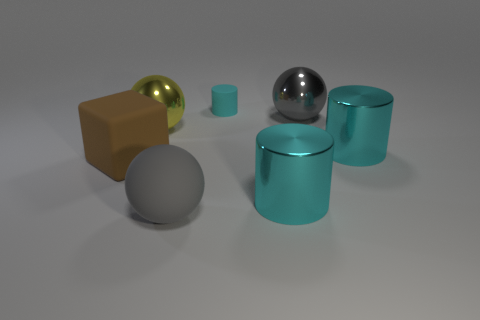Add 2 green shiny cylinders. How many objects exist? 9 Subtract all spheres. How many objects are left? 4 Add 5 big brown rubber objects. How many big brown rubber objects exist? 6 Subtract 0 red cubes. How many objects are left? 7 Subtract all large yellow metal spheres. Subtract all large green things. How many objects are left? 6 Add 6 big matte cubes. How many big matte cubes are left? 7 